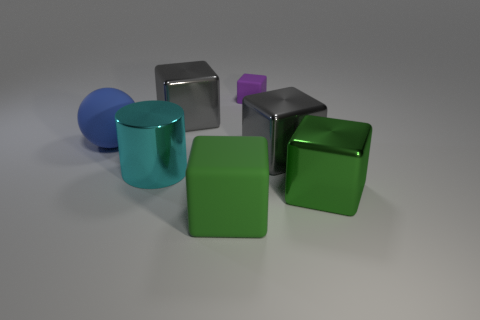Are there any tiny cyan metallic objects?
Offer a very short reply. No. Does the tiny thing have the same shape as the gray shiny thing that is in front of the large blue object?
Keep it short and to the point. Yes. The rubber block that is behind the large gray metal thing left of the green object that is left of the big green metal cube is what color?
Ensure brevity in your answer.  Purple. There is a large green rubber thing; are there any tiny blocks right of it?
Make the answer very short. Yes. There is another block that is the same color as the large matte block; what is its size?
Ensure brevity in your answer.  Large. Are there any big cubes that have the same material as the big blue object?
Offer a very short reply. Yes. What is the color of the large cylinder?
Offer a very short reply. Cyan. Is the shape of the big metallic object in front of the large metal cylinder the same as  the big green matte thing?
Keep it short and to the point. Yes. There is a shiny object that is behind the big matte ball behind the big green cube on the right side of the tiny purple thing; what is its shape?
Provide a short and direct response. Cube. There is a blue ball that is on the left side of the green rubber object; what material is it?
Offer a very short reply. Rubber. 